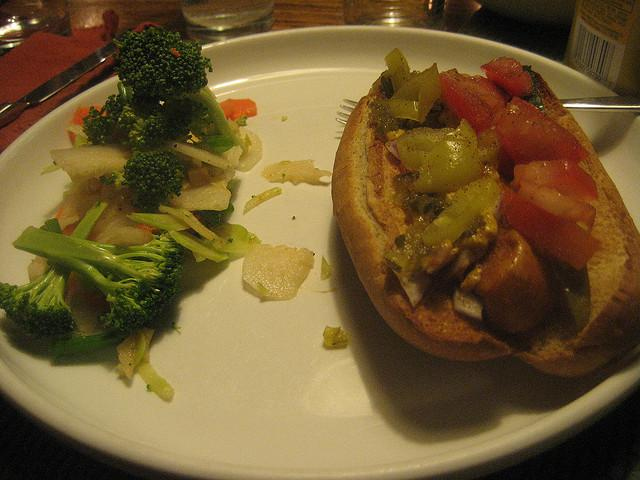What is on the left of the plate? Please explain your reasoning. broccoli. The vegetable that's green is broccoli. 